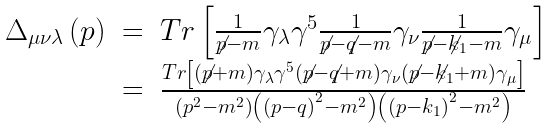<formula> <loc_0><loc_0><loc_500><loc_500>\begin{array} { r c l } \Delta _ { \mu \nu \lambda } \left ( p \right ) & = & T r \left [ \frac { 1 } { \not p - m } \gamma _ { \lambda } \gamma ^ { 5 } \frac { 1 } { \not p - \not q - m } \gamma _ { \nu } \frac { 1 } { \not p - \not k _ { 1 } - m } \gamma _ { \mu } \right ] \\ & = & \frac { T r \left [ \left ( \not p + m \right ) \gamma _ { \lambda } \gamma ^ { 5 } \left ( \not p - \not q + m \right ) \gamma _ { \nu } \left ( \not p - \not k _ { 1 } + m \right ) \gamma _ { \mu } \right ] } { \left ( p ^ { 2 } - m ^ { 2 } \right ) \left ( \left ( p - q \right ) ^ { 2 } - m ^ { 2 } \right ) \left ( \left ( p - k _ { 1 } \right ) ^ { 2 } - m ^ { 2 } \right ) } \end{array}</formula> 